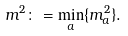Convert formula to latex. <formula><loc_0><loc_0><loc_500><loc_500>m ^ { 2 } \colon = \min _ { a } \{ m ^ { 2 } _ { a } \} .</formula> 